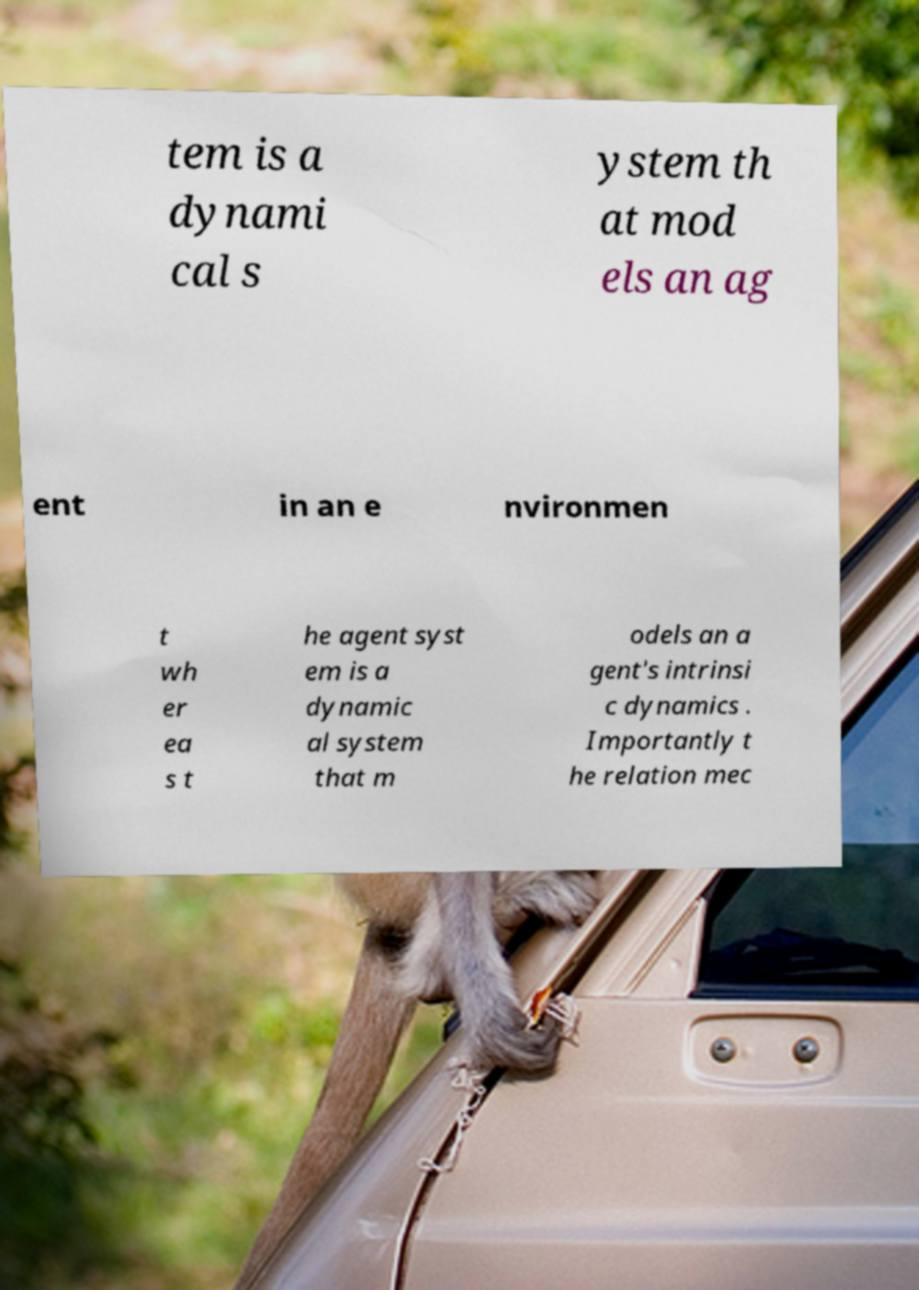Could you extract and type out the text from this image? tem is a dynami cal s ystem th at mod els an ag ent in an e nvironmen t wh er ea s t he agent syst em is a dynamic al system that m odels an a gent's intrinsi c dynamics . Importantly t he relation mec 